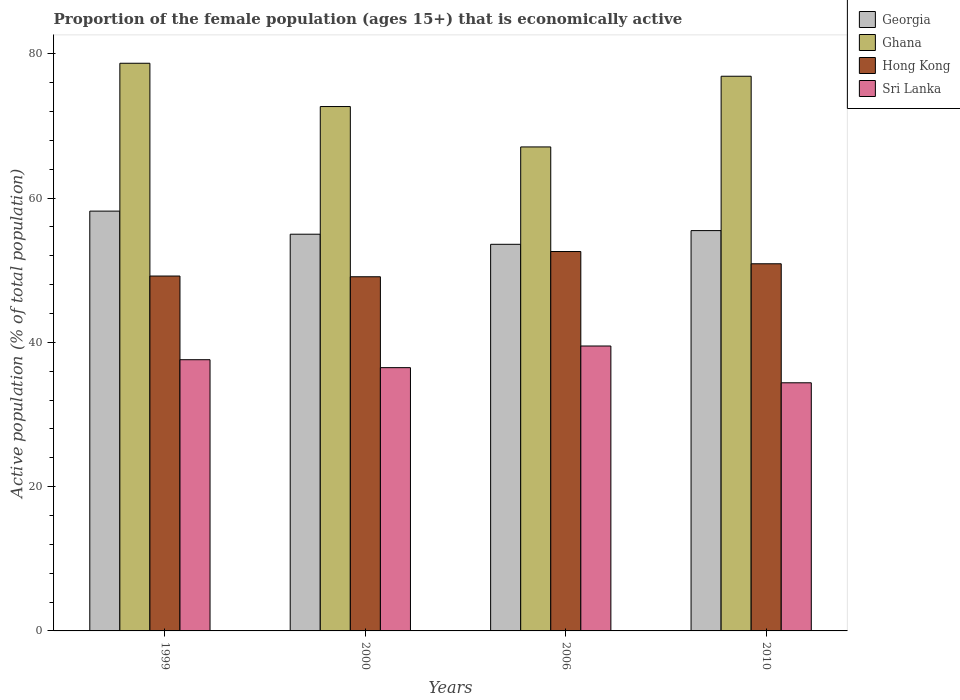How many groups of bars are there?
Your answer should be compact. 4. Are the number of bars per tick equal to the number of legend labels?
Give a very brief answer. Yes. How many bars are there on the 2nd tick from the left?
Offer a terse response. 4. How many bars are there on the 4th tick from the right?
Your answer should be very brief. 4. What is the label of the 4th group of bars from the left?
Your answer should be compact. 2010. In how many cases, is the number of bars for a given year not equal to the number of legend labels?
Your response must be concise. 0. What is the proportion of the female population that is economically active in Hong Kong in 2010?
Ensure brevity in your answer.  50.9. Across all years, what is the maximum proportion of the female population that is economically active in Sri Lanka?
Offer a very short reply. 39.5. Across all years, what is the minimum proportion of the female population that is economically active in Hong Kong?
Provide a succinct answer. 49.1. In which year was the proportion of the female population that is economically active in Ghana maximum?
Provide a succinct answer. 1999. In which year was the proportion of the female population that is economically active in Hong Kong minimum?
Ensure brevity in your answer.  2000. What is the total proportion of the female population that is economically active in Sri Lanka in the graph?
Offer a very short reply. 148. What is the difference between the proportion of the female population that is economically active in Georgia in 2006 and the proportion of the female population that is economically active in Sri Lanka in 1999?
Your answer should be very brief. 16. What is the average proportion of the female population that is economically active in Hong Kong per year?
Provide a succinct answer. 50.45. In the year 2000, what is the difference between the proportion of the female population that is economically active in Sri Lanka and proportion of the female population that is economically active in Ghana?
Make the answer very short. -36.2. In how many years, is the proportion of the female population that is economically active in Georgia greater than 32 %?
Make the answer very short. 4. What is the ratio of the proportion of the female population that is economically active in Ghana in 2000 to that in 2006?
Offer a very short reply. 1.08. Is the proportion of the female population that is economically active in Ghana in 2000 less than that in 2006?
Provide a succinct answer. No. Is the difference between the proportion of the female population that is economically active in Sri Lanka in 2000 and 2010 greater than the difference between the proportion of the female population that is economically active in Ghana in 2000 and 2010?
Keep it short and to the point. Yes. What is the difference between the highest and the second highest proportion of the female population that is economically active in Hong Kong?
Offer a very short reply. 1.7. What is the difference between the highest and the lowest proportion of the female population that is economically active in Ghana?
Give a very brief answer. 11.6. In how many years, is the proportion of the female population that is economically active in Georgia greater than the average proportion of the female population that is economically active in Georgia taken over all years?
Provide a short and direct response. 1. Is the sum of the proportion of the female population that is economically active in Georgia in 2000 and 2006 greater than the maximum proportion of the female population that is economically active in Hong Kong across all years?
Give a very brief answer. Yes. What does the 2nd bar from the left in 2006 represents?
Offer a very short reply. Ghana. What does the 2nd bar from the right in 2006 represents?
Make the answer very short. Hong Kong. Is it the case that in every year, the sum of the proportion of the female population that is economically active in Georgia and proportion of the female population that is economically active in Sri Lanka is greater than the proportion of the female population that is economically active in Hong Kong?
Give a very brief answer. Yes. Are all the bars in the graph horizontal?
Provide a short and direct response. No. Are the values on the major ticks of Y-axis written in scientific E-notation?
Your response must be concise. No. Does the graph contain any zero values?
Your response must be concise. No. Does the graph contain grids?
Your response must be concise. No. What is the title of the graph?
Your response must be concise. Proportion of the female population (ages 15+) that is economically active. Does "Bolivia" appear as one of the legend labels in the graph?
Your answer should be very brief. No. What is the label or title of the Y-axis?
Keep it short and to the point. Active population (% of total population). What is the Active population (% of total population) in Georgia in 1999?
Your answer should be very brief. 58.2. What is the Active population (% of total population) of Ghana in 1999?
Give a very brief answer. 78.7. What is the Active population (% of total population) in Hong Kong in 1999?
Give a very brief answer. 49.2. What is the Active population (% of total population) of Sri Lanka in 1999?
Your response must be concise. 37.6. What is the Active population (% of total population) in Georgia in 2000?
Provide a short and direct response. 55. What is the Active population (% of total population) in Ghana in 2000?
Offer a very short reply. 72.7. What is the Active population (% of total population) in Hong Kong in 2000?
Your response must be concise. 49.1. What is the Active population (% of total population) in Sri Lanka in 2000?
Make the answer very short. 36.5. What is the Active population (% of total population) of Georgia in 2006?
Your response must be concise. 53.6. What is the Active population (% of total population) in Ghana in 2006?
Your answer should be compact. 67.1. What is the Active population (% of total population) of Hong Kong in 2006?
Offer a very short reply. 52.6. What is the Active population (% of total population) of Sri Lanka in 2006?
Your answer should be very brief. 39.5. What is the Active population (% of total population) of Georgia in 2010?
Offer a terse response. 55.5. What is the Active population (% of total population) in Ghana in 2010?
Ensure brevity in your answer.  76.9. What is the Active population (% of total population) of Hong Kong in 2010?
Offer a very short reply. 50.9. What is the Active population (% of total population) in Sri Lanka in 2010?
Offer a terse response. 34.4. Across all years, what is the maximum Active population (% of total population) of Georgia?
Offer a terse response. 58.2. Across all years, what is the maximum Active population (% of total population) in Ghana?
Make the answer very short. 78.7. Across all years, what is the maximum Active population (% of total population) in Hong Kong?
Provide a succinct answer. 52.6. Across all years, what is the maximum Active population (% of total population) of Sri Lanka?
Offer a terse response. 39.5. Across all years, what is the minimum Active population (% of total population) of Georgia?
Ensure brevity in your answer.  53.6. Across all years, what is the minimum Active population (% of total population) in Ghana?
Provide a succinct answer. 67.1. Across all years, what is the minimum Active population (% of total population) of Hong Kong?
Keep it short and to the point. 49.1. Across all years, what is the minimum Active population (% of total population) of Sri Lanka?
Your response must be concise. 34.4. What is the total Active population (% of total population) in Georgia in the graph?
Offer a very short reply. 222.3. What is the total Active population (% of total population) of Ghana in the graph?
Offer a terse response. 295.4. What is the total Active population (% of total population) of Hong Kong in the graph?
Provide a short and direct response. 201.8. What is the total Active population (% of total population) in Sri Lanka in the graph?
Provide a succinct answer. 148. What is the difference between the Active population (% of total population) in Hong Kong in 1999 and that in 2000?
Give a very brief answer. 0.1. What is the difference between the Active population (% of total population) of Sri Lanka in 1999 and that in 2000?
Your answer should be compact. 1.1. What is the difference between the Active population (% of total population) of Sri Lanka in 1999 and that in 2006?
Your response must be concise. -1.9. What is the difference between the Active population (% of total population) of Georgia in 1999 and that in 2010?
Offer a very short reply. 2.7. What is the difference between the Active population (% of total population) of Ghana in 1999 and that in 2010?
Offer a very short reply. 1.8. What is the difference between the Active population (% of total population) in Hong Kong in 1999 and that in 2010?
Keep it short and to the point. -1.7. What is the difference between the Active population (% of total population) of Georgia in 2000 and that in 2006?
Your answer should be very brief. 1.4. What is the difference between the Active population (% of total population) in Ghana in 2000 and that in 2006?
Provide a short and direct response. 5.6. What is the difference between the Active population (% of total population) of Ghana in 2000 and that in 2010?
Keep it short and to the point. -4.2. What is the difference between the Active population (% of total population) in Hong Kong in 2000 and that in 2010?
Offer a terse response. -1.8. What is the difference between the Active population (% of total population) in Sri Lanka in 2000 and that in 2010?
Ensure brevity in your answer.  2.1. What is the difference between the Active population (% of total population) of Georgia in 2006 and that in 2010?
Offer a very short reply. -1.9. What is the difference between the Active population (% of total population) in Ghana in 2006 and that in 2010?
Provide a short and direct response. -9.8. What is the difference between the Active population (% of total population) in Sri Lanka in 2006 and that in 2010?
Keep it short and to the point. 5.1. What is the difference between the Active population (% of total population) in Georgia in 1999 and the Active population (% of total population) in Ghana in 2000?
Ensure brevity in your answer.  -14.5. What is the difference between the Active population (% of total population) of Georgia in 1999 and the Active population (% of total population) of Hong Kong in 2000?
Your answer should be compact. 9.1. What is the difference between the Active population (% of total population) in Georgia in 1999 and the Active population (% of total population) in Sri Lanka in 2000?
Make the answer very short. 21.7. What is the difference between the Active population (% of total population) in Ghana in 1999 and the Active population (% of total population) in Hong Kong in 2000?
Offer a terse response. 29.6. What is the difference between the Active population (% of total population) in Ghana in 1999 and the Active population (% of total population) in Sri Lanka in 2000?
Provide a succinct answer. 42.2. What is the difference between the Active population (% of total population) in Georgia in 1999 and the Active population (% of total population) in Hong Kong in 2006?
Keep it short and to the point. 5.6. What is the difference between the Active population (% of total population) in Georgia in 1999 and the Active population (% of total population) in Sri Lanka in 2006?
Your answer should be very brief. 18.7. What is the difference between the Active population (% of total population) of Ghana in 1999 and the Active population (% of total population) of Hong Kong in 2006?
Provide a short and direct response. 26.1. What is the difference between the Active population (% of total population) of Ghana in 1999 and the Active population (% of total population) of Sri Lanka in 2006?
Your answer should be very brief. 39.2. What is the difference between the Active population (% of total population) in Hong Kong in 1999 and the Active population (% of total population) in Sri Lanka in 2006?
Make the answer very short. 9.7. What is the difference between the Active population (% of total population) in Georgia in 1999 and the Active population (% of total population) in Ghana in 2010?
Your answer should be very brief. -18.7. What is the difference between the Active population (% of total population) of Georgia in 1999 and the Active population (% of total population) of Hong Kong in 2010?
Provide a short and direct response. 7.3. What is the difference between the Active population (% of total population) of Georgia in 1999 and the Active population (% of total population) of Sri Lanka in 2010?
Provide a short and direct response. 23.8. What is the difference between the Active population (% of total population) of Ghana in 1999 and the Active population (% of total population) of Hong Kong in 2010?
Your response must be concise. 27.8. What is the difference between the Active population (% of total population) in Ghana in 1999 and the Active population (% of total population) in Sri Lanka in 2010?
Keep it short and to the point. 44.3. What is the difference between the Active population (% of total population) in Georgia in 2000 and the Active population (% of total population) in Hong Kong in 2006?
Keep it short and to the point. 2.4. What is the difference between the Active population (% of total population) of Ghana in 2000 and the Active population (% of total population) of Hong Kong in 2006?
Offer a very short reply. 20.1. What is the difference between the Active population (% of total population) of Ghana in 2000 and the Active population (% of total population) of Sri Lanka in 2006?
Offer a very short reply. 33.2. What is the difference between the Active population (% of total population) in Georgia in 2000 and the Active population (% of total population) in Ghana in 2010?
Provide a short and direct response. -21.9. What is the difference between the Active population (% of total population) in Georgia in 2000 and the Active population (% of total population) in Hong Kong in 2010?
Make the answer very short. 4.1. What is the difference between the Active population (% of total population) of Georgia in 2000 and the Active population (% of total population) of Sri Lanka in 2010?
Give a very brief answer. 20.6. What is the difference between the Active population (% of total population) of Ghana in 2000 and the Active population (% of total population) of Hong Kong in 2010?
Provide a succinct answer. 21.8. What is the difference between the Active population (% of total population) in Ghana in 2000 and the Active population (% of total population) in Sri Lanka in 2010?
Offer a very short reply. 38.3. What is the difference between the Active population (% of total population) in Hong Kong in 2000 and the Active population (% of total population) in Sri Lanka in 2010?
Keep it short and to the point. 14.7. What is the difference between the Active population (% of total population) of Georgia in 2006 and the Active population (% of total population) of Ghana in 2010?
Ensure brevity in your answer.  -23.3. What is the difference between the Active population (% of total population) of Georgia in 2006 and the Active population (% of total population) of Sri Lanka in 2010?
Your answer should be compact. 19.2. What is the difference between the Active population (% of total population) of Ghana in 2006 and the Active population (% of total population) of Sri Lanka in 2010?
Provide a short and direct response. 32.7. What is the difference between the Active population (% of total population) of Hong Kong in 2006 and the Active population (% of total population) of Sri Lanka in 2010?
Give a very brief answer. 18.2. What is the average Active population (% of total population) in Georgia per year?
Your answer should be very brief. 55.58. What is the average Active population (% of total population) of Ghana per year?
Your answer should be compact. 73.85. What is the average Active population (% of total population) of Hong Kong per year?
Make the answer very short. 50.45. In the year 1999, what is the difference between the Active population (% of total population) in Georgia and Active population (% of total population) in Ghana?
Give a very brief answer. -20.5. In the year 1999, what is the difference between the Active population (% of total population) of Georgia and Active population (% of total population) of Sri Lanka?
Ensure brevity in your answer.  20.6. In the year 1999, what is the difference between the Active population (% of total population) of Ghana and Active population (% of total population) of Hong Kong?
Provide a succinct answer. 29.5. In the year 1999, what is the difference between the Active population (% of total population) in Ghana and Active population (% of total population) in Sri Lanka?
Give a very brief answer. 41.1. In the year 1999, what is the difference between the Active population (% of total population) of Hong Kong and Active population (% of total population) of Sri Lanka?
Your answer should be compact. 11.6. In the year 2000, what is the difference between the Active population (% of total population) of Georgia and Active population (% of total population) of Ghana?
Offer a terse response. -17.7. In the year 2000, what is the difference between the Active population (% of total population) in Georgia and Active population (% of total population) in Sri Lanka?
Your response must be concise. 18.5. In the year 2000, what is the difference between the Active population (% of total population) in Ghana and Active population (% of total population) in Hong Kong?
Provide a short and direct response. 23.6. In the year 2000, what is the difference between the Active population (% of total population) of Ghana and Active population (% of total population) of Sri Lanka?
Keep it short and to the point. 36.2. In the year 2006, what is the difference between the Active population (% of total population) in Georgia and Active population (% of total population) in Ghana?
Your answer should be very brief. -13.5. In the year 2006, what is the difference between the Active population (% of total population) of Georgia and Active population (% of total population) of Hong Kong?
Provide a short and direct response. 1. In the year 2006, what is the difference between the Active population (% of total population) of Georgia and Active population (% of total population) of Sri Lanka?
Your response must be concise. 14.1. In the year 2006, what is the difference between the Active population (% of total population) of Ghana and Active population (% of total population) of Sri Lanka?
Provide a succinct answer. 27.6. In the year 2010, what is the difference between the Active population (% of total population) in Georgia and Active population (% of total population) in Ghana?
Your answer should be compact. -21.4. In the year 2010, what is the difference between the Active population (% of total population) in Georgia and Active population (% of total population) in Hong Kong?
Your response must be concise. 4.6. In the year 2010, what is the difference between the Active population (% of total population) of Georgia and Active population (% of total population) of Sri Lanka?
Your answer should be compact. 21.1. In the year 2010, what is the difference between the Active population (% of total population) of Ghana and Active population (% of total population) of Hong Kong?
Offer a terse response. 26. In the year 2010, what is the difference between the Active population (% of total population) in Ghana and Active population (% of total population) in Sri Lanka?
Your response must be concise. 42.5. In the year 2010, what is the difference between the Active population (% of total population) in Hong Kong and Active population (% of total population) in Sri Lanka?
Provide a succinct answer. 16.5. What is the ratio of the Active population (% of total population) in Georgia in 1999 to that in 2000?
Your answer should be compact. 1.06. What is the ratio of the Active population (% of total population) in Ghana in 1999 to that in 2000?
Keep it short and to the point. 1.08. What is the ratio of the Active population (% of total population) in Hong Kong in 1999 to that in 2000?
Keep it short and to the point. 1. What is the ratio of the Active population (% of total population) in Sri Lanka in 1999 to that in 2000?
Your response must be concise. 1.03. What is the ratio of the Active population (% of total population) of Georgia in 1999 to that in 2006?
Offer a terse response. 1.09. What is the ratio of the Active population (% of total population) of Ghana in 1999 to that in 2006?
Keep it short and to the point. 1.17. What is the ratio of the Active population (% of total population) in Hong Kong in 1999 to that in 2006?
Provide a succinct answer. 0.94. What is the ratio of the Active population (% of total population) in Sri Lanka in 1999 to that in 2006?
Offer a terse response. 0.95. What is the ratio of the Active population (% of total population) of Georgia in 1999 to that in 2010?
Provide a succinct answer. 1.05. What is the ratio of the Active population (% of total population) of Ghana in 1999 to that in 2010?
Your answer should be compact. 1.02. What is the ratio of the Active population (% of total population) in Hong Kong in 1999 to that in 2010?
Ensure brevity in your answer.  0.97. What is the ratio of the Active population (% of total population) of Sri Lanka in 1999 to that in 2010?
Provide a short and direct response. 1.09. What is the ratio of the Active population (% of total population) in Georgia in 2000 to that in 2006?
Your response must be concise. 1.03. What is the ratio of the Active population (% of total population) of Ghana in 2000 to that in 2006?
Your answer should be compact. 1.08. What is the ratio of the Active population (% of total population) in Hong Kong in 2000 to that in 2006?
Make the answer very short. 0.93. What is the ratio of the Active population (% of total population) of Sri Lanka in 2000 to that in 2006?
Ensure brevity in your answer.  0.92. What is the ratio of the Active population (% of total population) of Georgia in 2000 to that in 2010?
Your response must be concise. 0.99. What is the ratio of the Active population (% of total population) in Ghana in 2000 to that in 2010?
Provide a short and direct response. 0.95. What is the ratio of the Active population (% of total population) of Hong Kong in 2000 to that in 2010?
Ensure brevity in your answer.  0.96. What is the ratio of the Active population (% of total population) of Sri Lanka in 2000 to that in 2010?
Offer a terse response. 1.06. What is the ratio of the Active population (% of total population) in Georgia in 2006 to that in 2010?
Your response must be concise. 0.97. What is the ratio of the Active population (% of total population) in Ghana in 2006 to that in 2010?
Provide a succinct answer. 0.87. What is the ratio of the Active population (% of total population) of Hong Kong in 2006 to that in 2010?
Provide a succinct answer. 1.03. What is the ratio of the Active population (% of total population) in Sri Lanka in 2006 to that in 2010?
Your answer should be very brief. 1.15. What is the difference between the highest and the second highest Active population (% of total population) in Georgia?
Keep it short and to the point. 2.7. What is the difference between the highest and the second highest Active population (% of total population) of Sri Lanka?
Give a very brief answer. 1.9. What is the difference between the highest and the lowest Active population (% of total population) in Ghana?
Provide a succinct answer. 11.6. What is the difference between the highest and the lowest Active population (% of total population) of Hong Kong?
Provide a short and direct response. 3.5. What is the difference between the highest and the lowest Active population (% of total population) of Sri Lanka?
Your answer should be very brief. 5.1. 